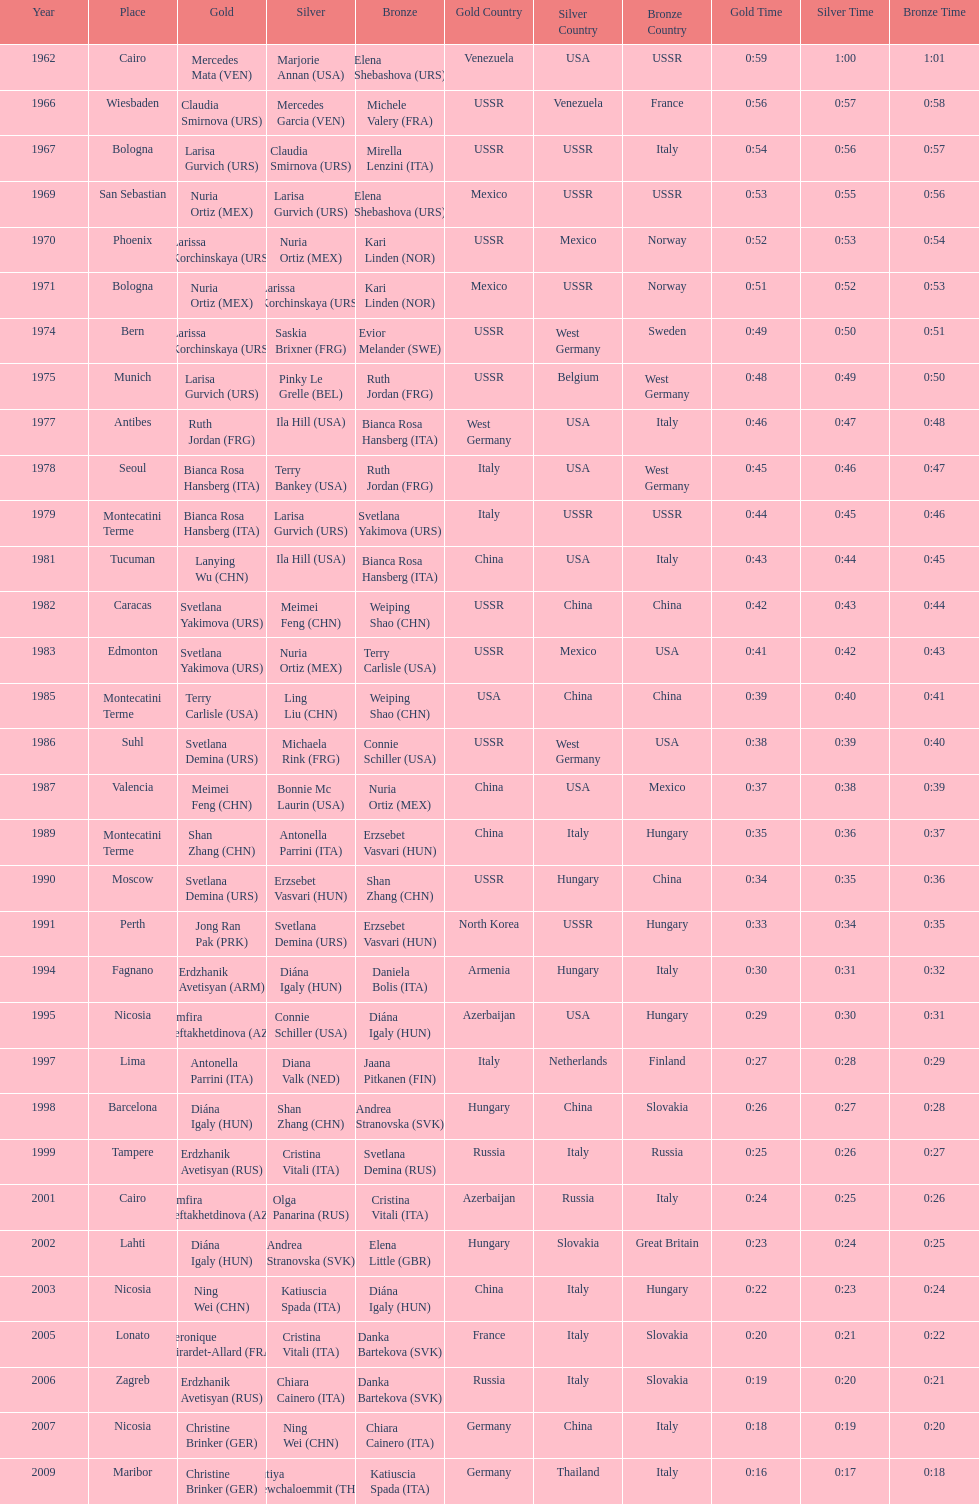How many gold did u.s.a win 1. 